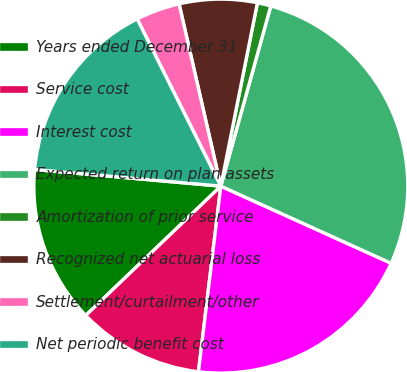<chart> <loc_0><loc_0><loc_500><loc_500><pie_chart><fcel>Years ended December 31<fcel>Service cost<fcel>Interest cost<fcel>Expected return on plan assets<fcel>Amortization of prior service<fcel>Recognized net actuarial loss<fcel>Settlement/curtailment/other<fcel>Net periodic benefit cost<nl><fcel>13.57%<fcel>10.94%<fcel>20.14%<fcel>27.46%<fcel>1.17%<fcel>6.72%<fcel>3.8%<fcel>16.2%<nl></chart> 